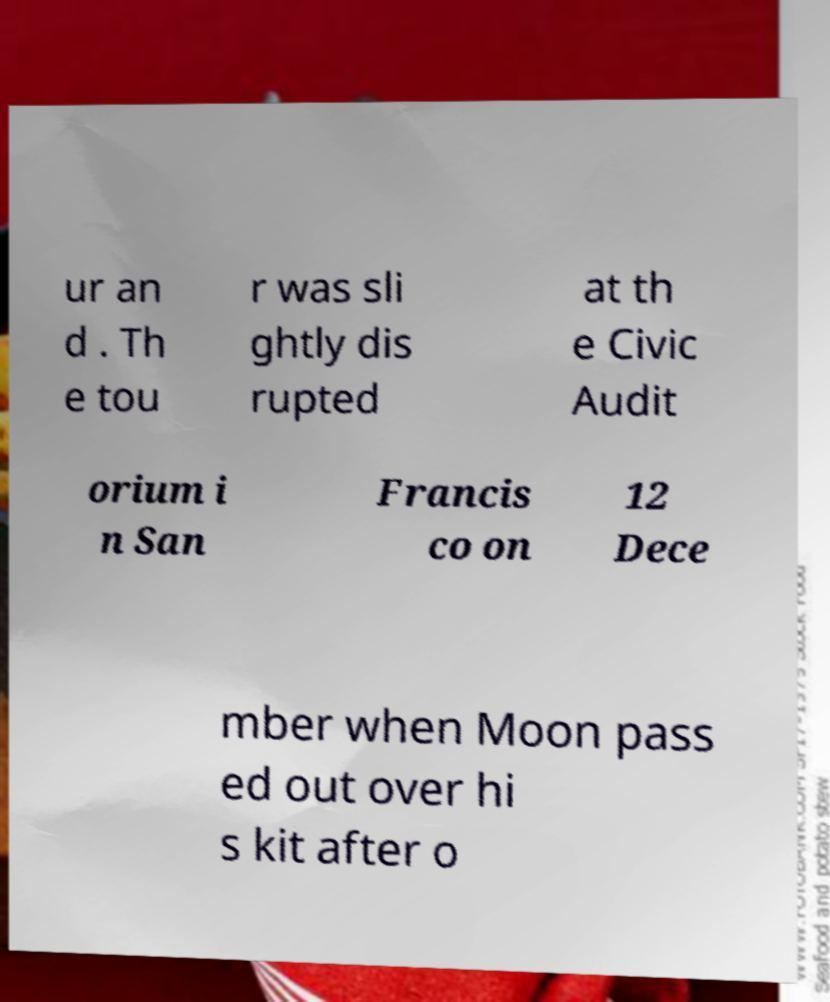Can you read and provide the text displayed in the image?This photo seems to have some interesting text. Can you extract and type it out for me? ur an d . Th e tou r was sli ghtly dis rupted at th e Civic Audit orium i n San Francis co on 12 Dece mber when Moon pass ed out over hi s kit after o 